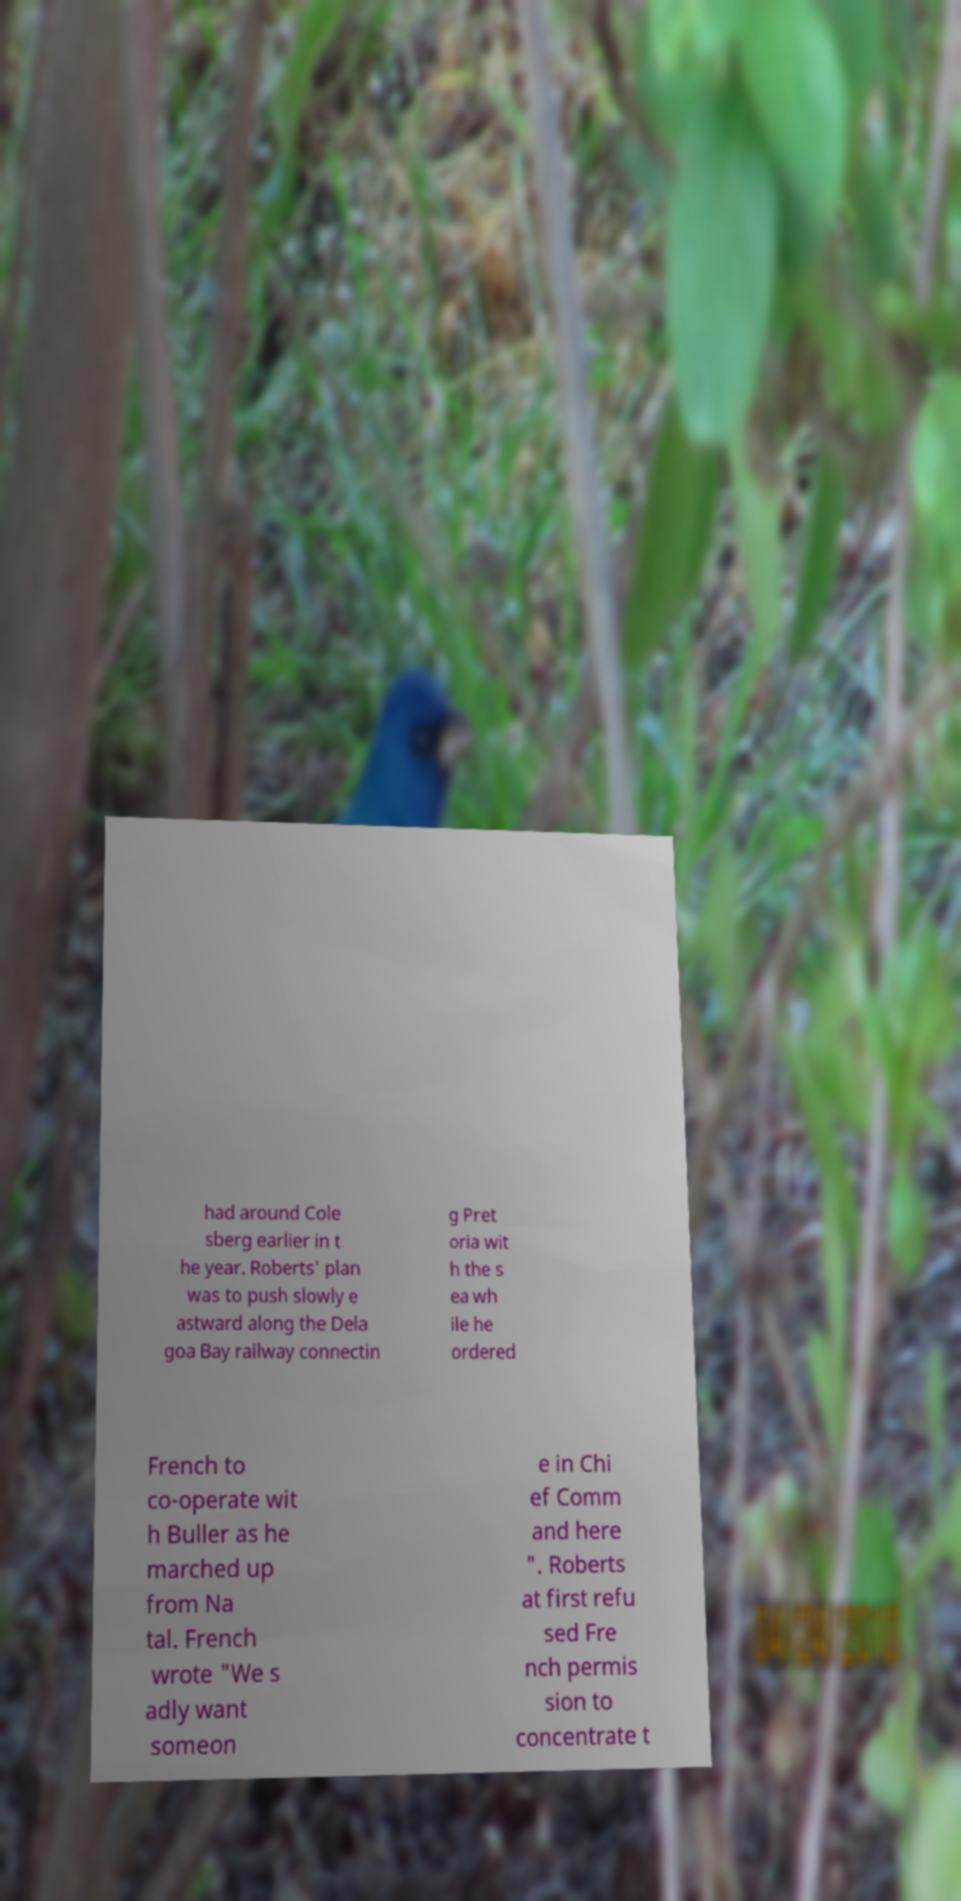Can you read and provide the text displayed in the image?This photo seems to have some interesting text. Can you extract and type it out for me? had around Cole sberg earlier in t he year. Roberts' plan was to push slowly e astward along the Dela goa Bay railway connectin g Pret oria wit h the s ea wh ile he ordered French to co-operate wit h Buller as he marched up from Na tal. French wrote "We s adly want someon e in Chi ef Comm and here ". Roberts at first refu sed Fre nch permis sion to concentrate t 